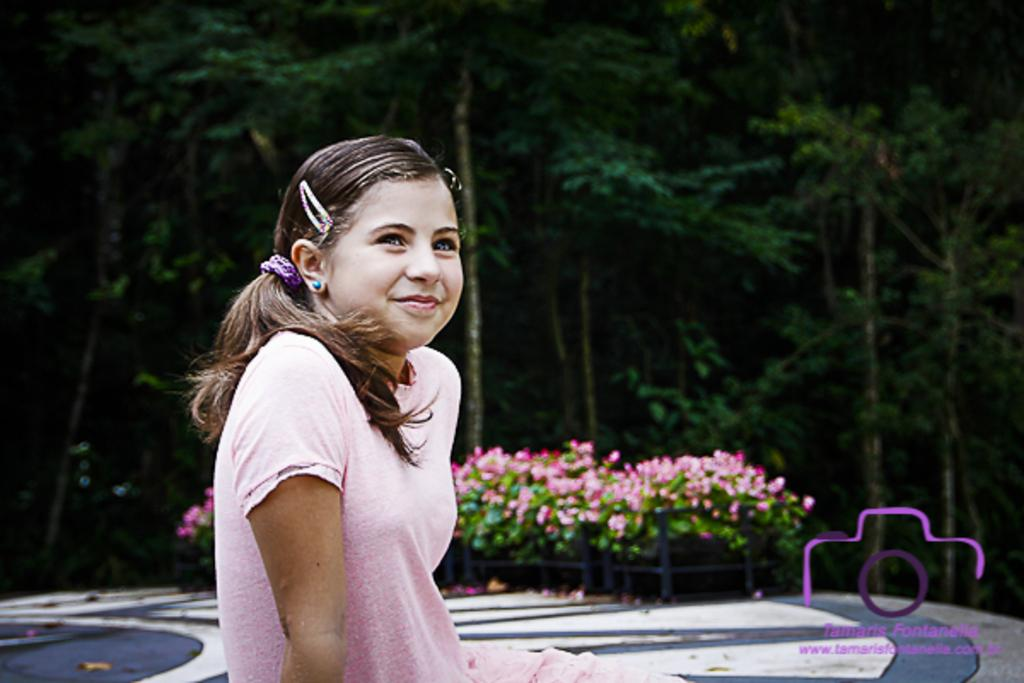Who is the main subject in the image? There is a lady in the image. What is the lady wearing? The lady is wearing a pink dress. What is the lady doing in the image? The lady is sitting. What can be seen in the background of the image? There are plants and trees in the background of the image. What is present in the right bottom corner of the image? There is text or an image in the right bottom corner of the image. How many ants can be seen crawling on the lady's pink dress in the image? There are no ants present in the image; the lady is wearing a pink dress while sitting. Is there a beggar visible in the image? There is no beggar present in the image; the main subject is a lady wearing a pink dress and sitting. 